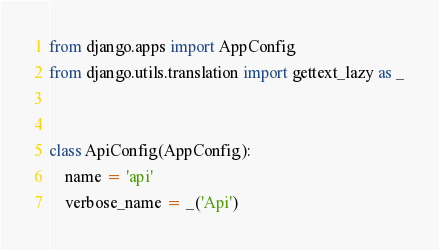Convert code to text. <code><loc_0><loc_0><loc_500><loc_500><_Python_>from django.apps import AppConfig
from django.utils.translation import gettext_lazy as _


class ApiConfig(AppConfig):
    name = 'api'
    verbose_name = _('Api')
</code> 